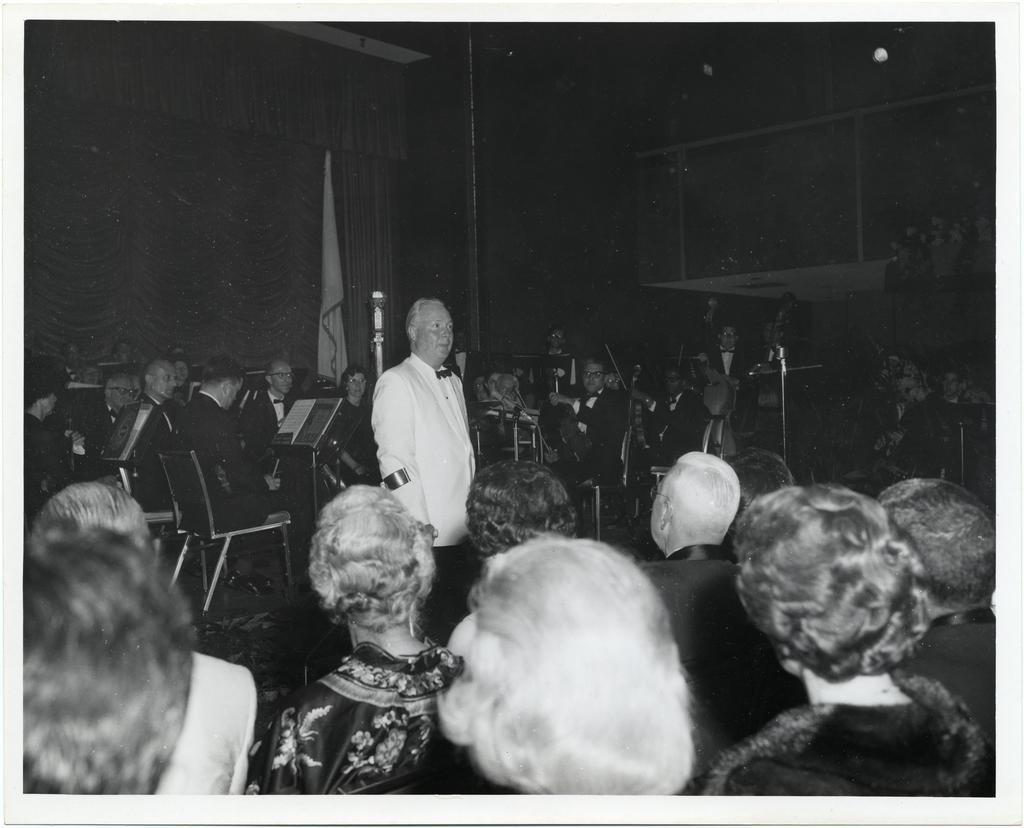Can you describe this image briefly? In this picture there is a man who is standing in the center of the image and there are people at the bottom side of the image and there are people those who are sitting in front of the books in the background area of the image, there are cupboards and a lamp in the image. 